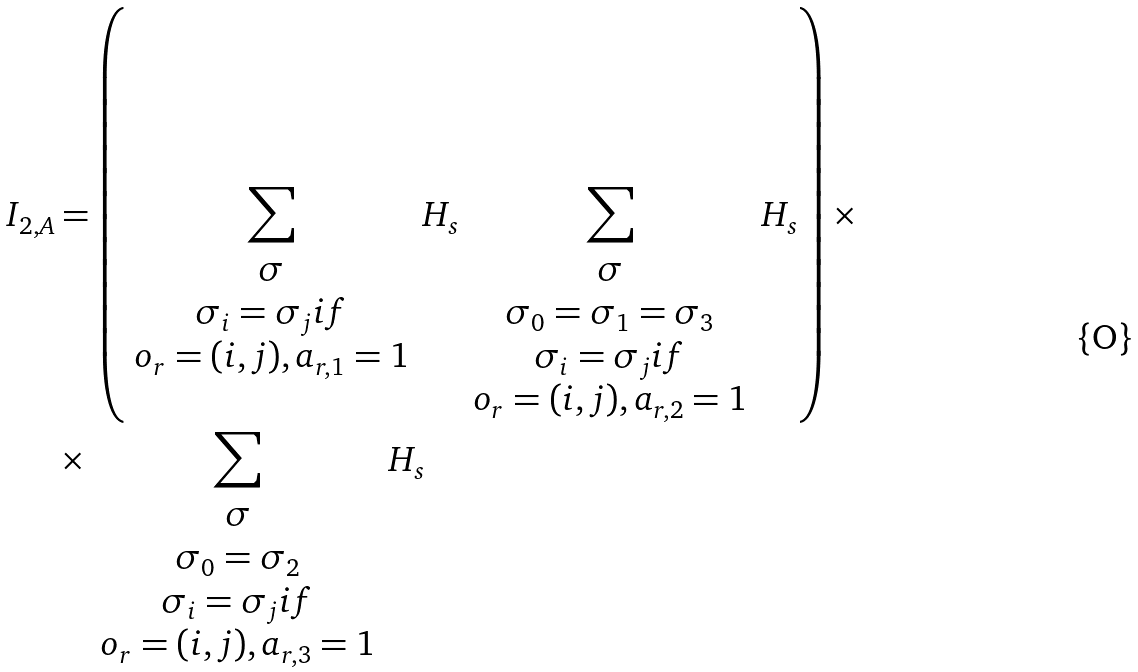Convert formula to latex. <formula><loc_0><loc_0><loc_500><loc_500>I _ { 2 , A } & = \left ( \sum _ { \begin{array} { c } \sigma \\ \sigma _ { i } = \sigma _ { j } i f \\ o _ { r } = ( i , j ) , a _ { r , 1 } = 1 \end{array} } H _ { s } \sum _ { \begin{array} { c } \sigma \\ \sigma _ { 0 } = \sigma _ { 1 } = \sigma _ { 3 } \\ \sigma _ { i } = \sigma _ { j } i f \\ o _ { r } = ( i , j ) , a _ { r , 2 } = 1 \end{array} } H _ { s } \right ) \times \\ & \times \sum _ { \begin{array} { c } \sigma \\ \sigma _ { 0 } = \sigma _ { 2 } \\ \sigma _ { i } = \sigma _ { j } i f \\ o _ { r } = ( i , j ) , a _ { r , 3 } = 1 \end{array} } H _ { s }</formula> 